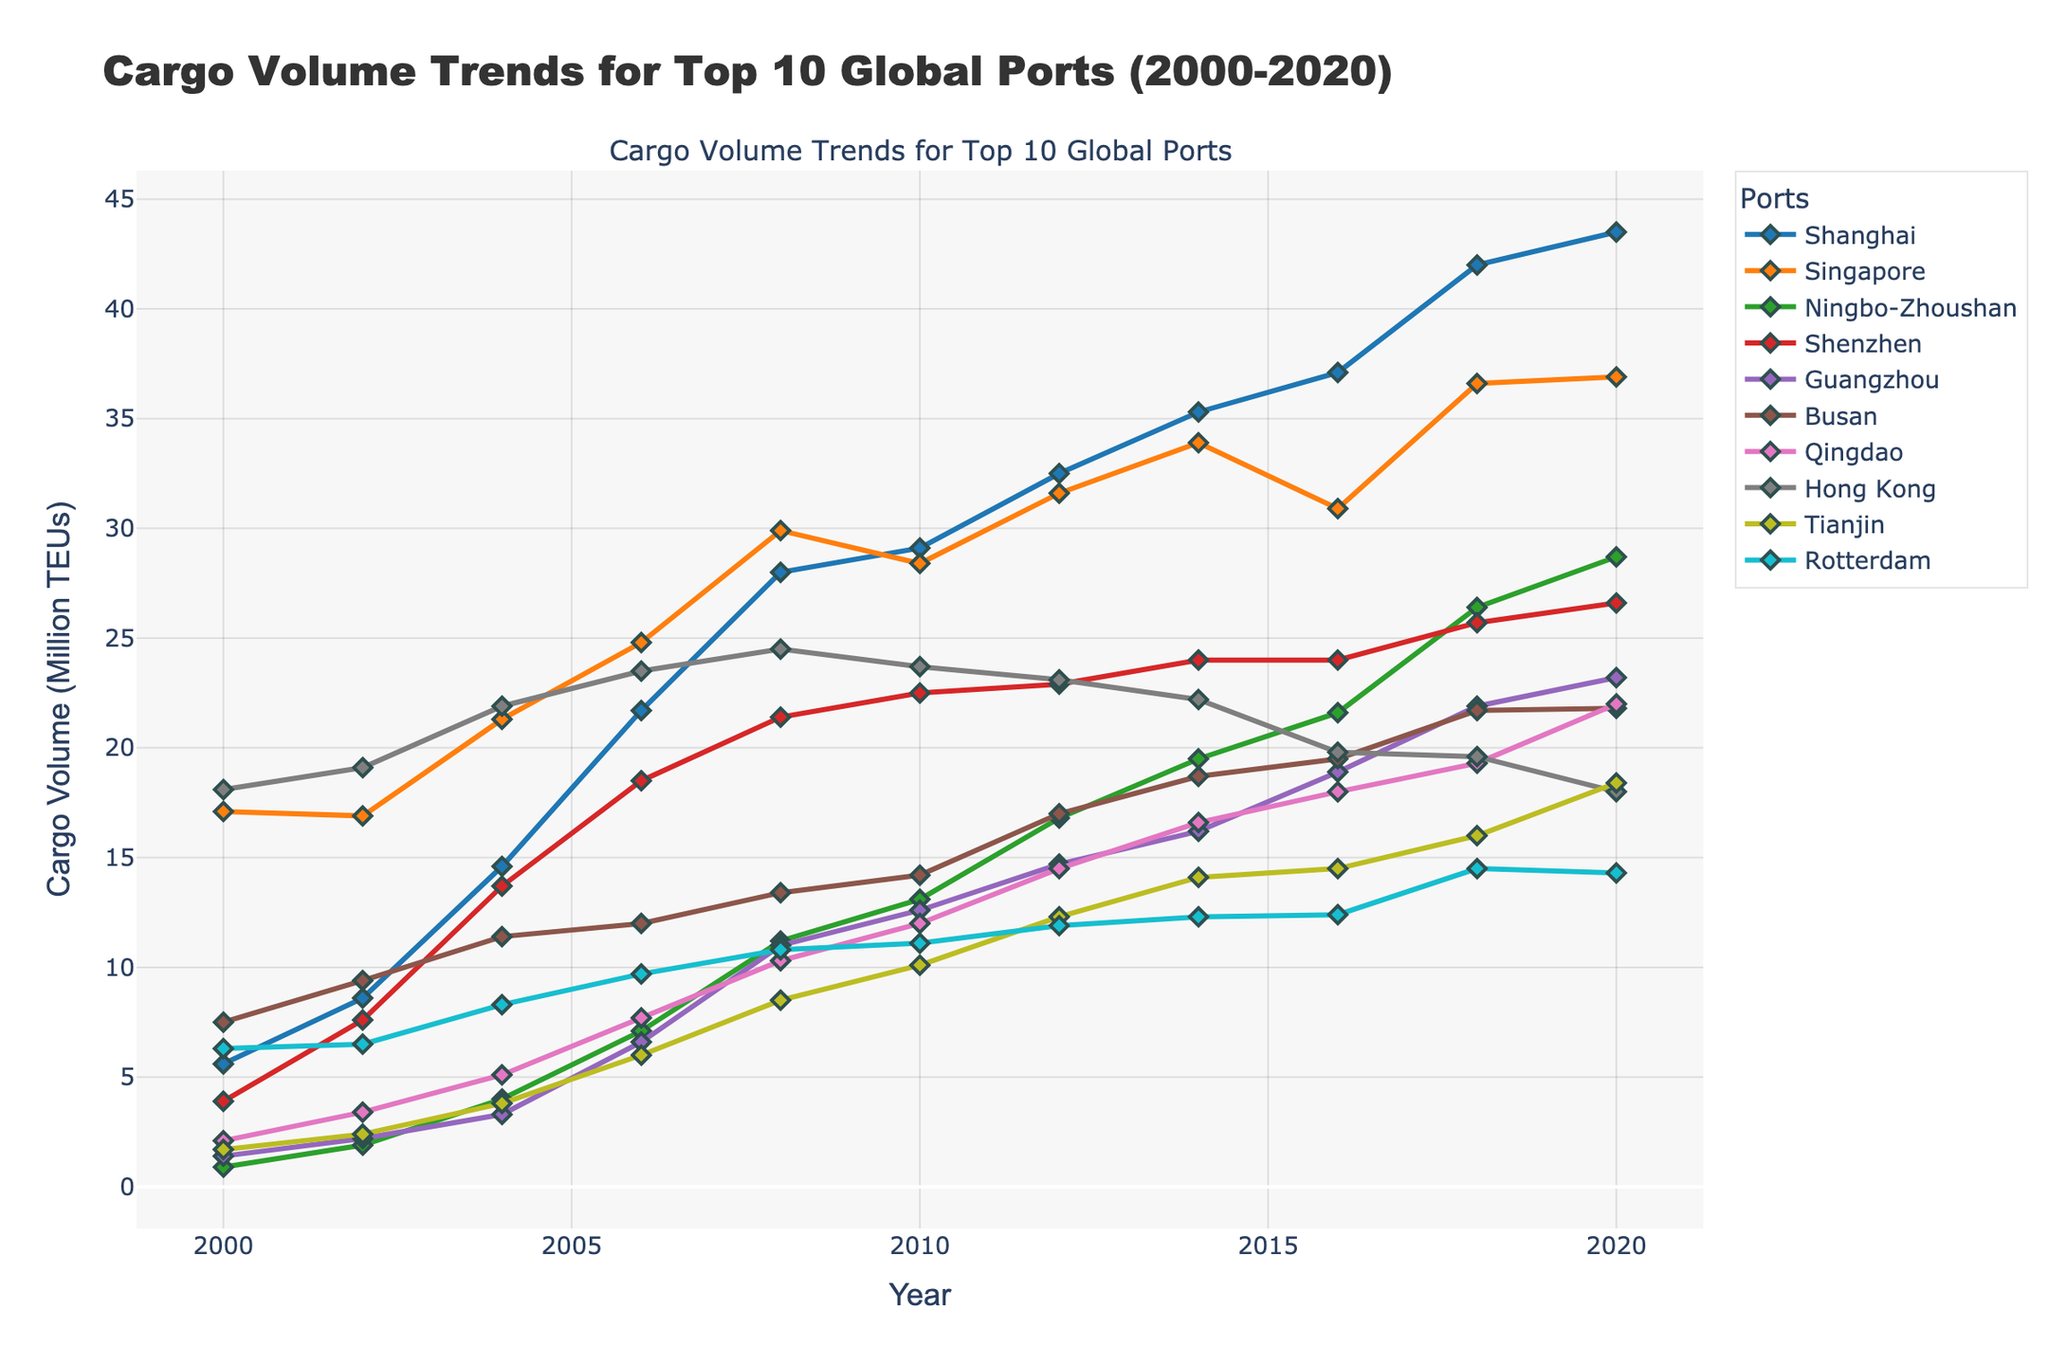Which port has the highest cargo volume in 2020? Look at the data points for the year 2020, and compare the heights of the lines representing each port. The port with the highest data point is Shanghai.
Answer: Shanghai What is the trend in cargo volume for Ningbo-Zhoushan from 2000 to 2020? Observe the slope of the line representing Ningbo-Zhoushan over the years. The line starts low in 2000 and increases steadily over time, reaching a peak in 2020.
Answer: Increasing Which port had the most significant increase in cargo volume between 2000 and 2020? Calculate the difference between the cargo volume in 2020 and 2000 for each port. Shanghai had the most significant increase, from 5.6 to 43.5 million TEUs.
Answer: Shanghai Between 2008 and 2012, which port showed the smallest change in cargo volume? Look at the data points for each port in 2008 and 2012, and calculate the difference. Hong Kong's cargo volume changed the least, from 24.5 to 23.1, a decrease of 1.4 million TEUs.
Answer: Hong Kong Compare the cargo volumes of Busan and Rotterdam in 2016. Which port had a higher volume? Look at the data points for Busan and Rotterdam in 2016. Busan had a cargo volume of 19.5, whereas Rotterdam had 12.4. Hence, Busan had a higher volume.
Answer: Busan What is the average cargo volume for Singapore over the entire period? Sum the cargo volumes for Singapore from 2000 to 2020 and divide by the number of years (11). The sum is (17.1 + 16.9 + 21.3 + 24.8 + 29.9 + 28.4 + 31.6 + 33.9 + 30.9 + 36.6 + 36.9) = 308.3. The average is 308.3 / 11 = 28.03.
Answer: 28.03 Describe the cargo volume trend for Hong Kong from 2000 to 2020. Observe the changes in the data points for Hong Kong over the years. The line shows an initial increase, then remains relatively flat and even decreases slightly after 2010, ending at 18.0 in 2020.
Answer: Gradual decrease In which year did Guangzhou experience the largest increase in cargo volume compared to the previous year? Calculate the year-on-year differences in cargo volume for Guangzhou, and find the maximum increase. The largest increase was from 2014 to 2016 (18.9 - 16.2 = 2.7).
Answer: 2016 Which two ports had the closest cargo volumes in 2020? Compare the cargo volumes for all ports in 2020. Singapore (36.9) and Busan (21.8) are closest to each other in terms of difference.
Answer: Singapore and Busan What is the primary color used to represent the port of Rotterdam in the chart? Identify the color of the line and markers used for Rotterdam. The color is light blue.
Answer: Light blue 